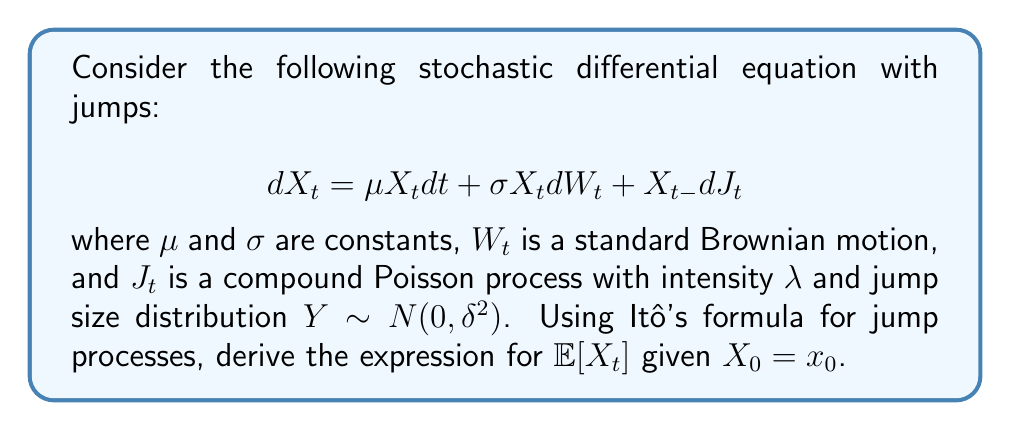Help me with this question. Let's approach this step-by-step:

1) First, we need to apply Itô's formula for jump processes to $\ln(X_t)$. Let $f(x) = \ln(x)$. Then:

   $$d\ln(X_t) = \frac{1}{X_t}dX_t - \frac{1}{2X_t^2}(dX_t)^2 + [\ln(X_t) - \ln(X_{t-})]$$

2) Substituting the given SDE and simplifying:

   $$d\ln(X_t) = (\mu - \frac{1}{2}\sigma^2)dt + \sigma dW_t + \ln(1 + dJ_t)$$

3) Integrating both sides from 0 to t:

   $$\ln(X_t) - \ln(X_0) = (\mu - \frac{1}{2}\sigma^2)t + \sigma W_t + \sum_{i=1}^{N_t} \ln(1 + Y_i)$$

   where $N_t$ is the number of jumps up to time t.

4) Exponentiating both sides:

   $$X_t = X_0 \exp\{(\mu - \frac{1}{2}\sigma^2)t + \sigma W_t\} \prod_{i=1}^{N_t} (1 + Y_i)$$

5) Now, we need to take the expectation of both sides. Note that $W_t$, $N_t$, and $Y_i$ are independent:

   $$\mathbb{E}[X_t] = x_0 \exp\{(\mu - \frac{1}{2}\sigma^2)t\} \mathbb{E}[\exp(\sigma W_t)] \mathbb{E}[\prod_{i=1}^{N_t} (1 + Y_i)]$$

6) We know that $\mathbb{E}[\exp(\sigma W_t)] = \exp(\frac{1}{2}\sigma^2 t)$

7) For the jump term:
   
   $$\mathbb{E}[\prod_{i=1}^{N_t} (1 + Y_i)] = \mathbb{E}[\mathbb{E}[\prod_{i=1}^{N_t} (1 + Y_i) | N_t]] = \mathbb{E}[(1 + \delta^2)^{N_t}]$$

8) Since $N_t$ follows a Poisson distribution with parameter $\lambda t$:

   $$\mathbb{E}[(1 + \delta^2)^{N_t}] = \exp(\lambda t ((1 + \delta^2) - 1)) = \exp(\lambda t \delta^2)$$

9) Combining all terms:

   $$\mathbb{E}[X_t] = x_0 \exp\{(\mu + \lambda \delta^2)t\}$$
Answer: $x_0 \exp\{(\mu + \lambda \delta^2)t\}$ 